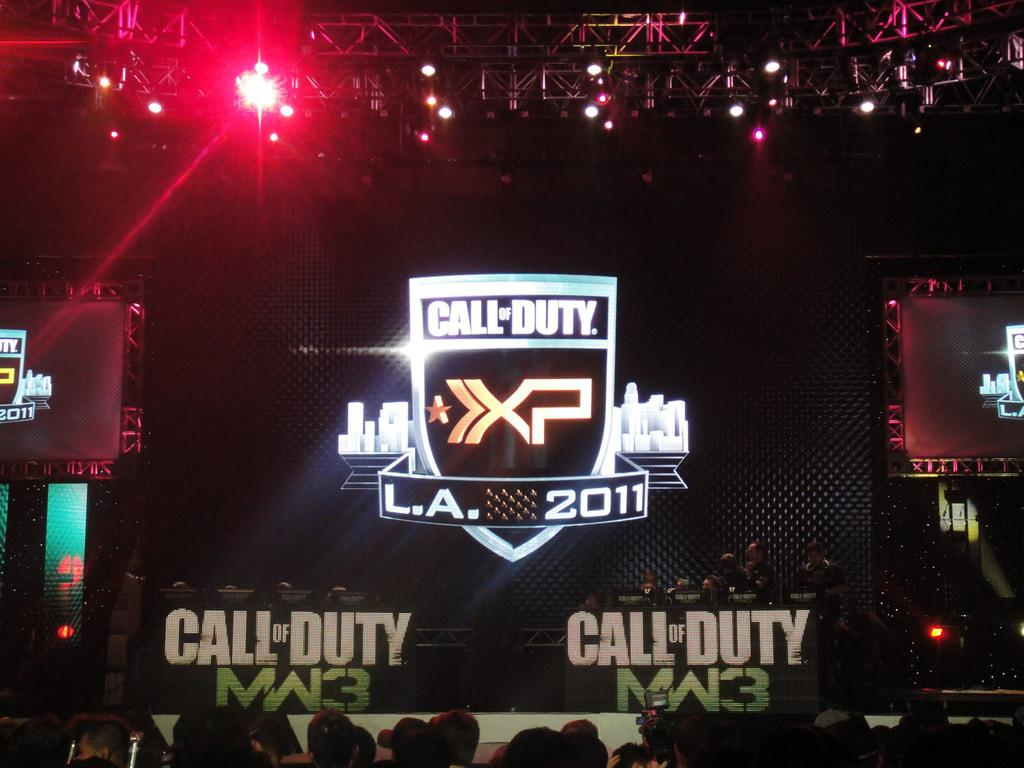<image>
Give a short and clear explanation of the subsequent image. A Call of Duty event displays a logo with a 2011 date. 